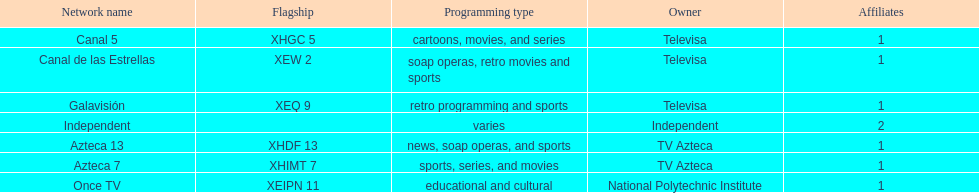Azteca 7 and azteca 13 are both owned by whom? TV Azteca. 